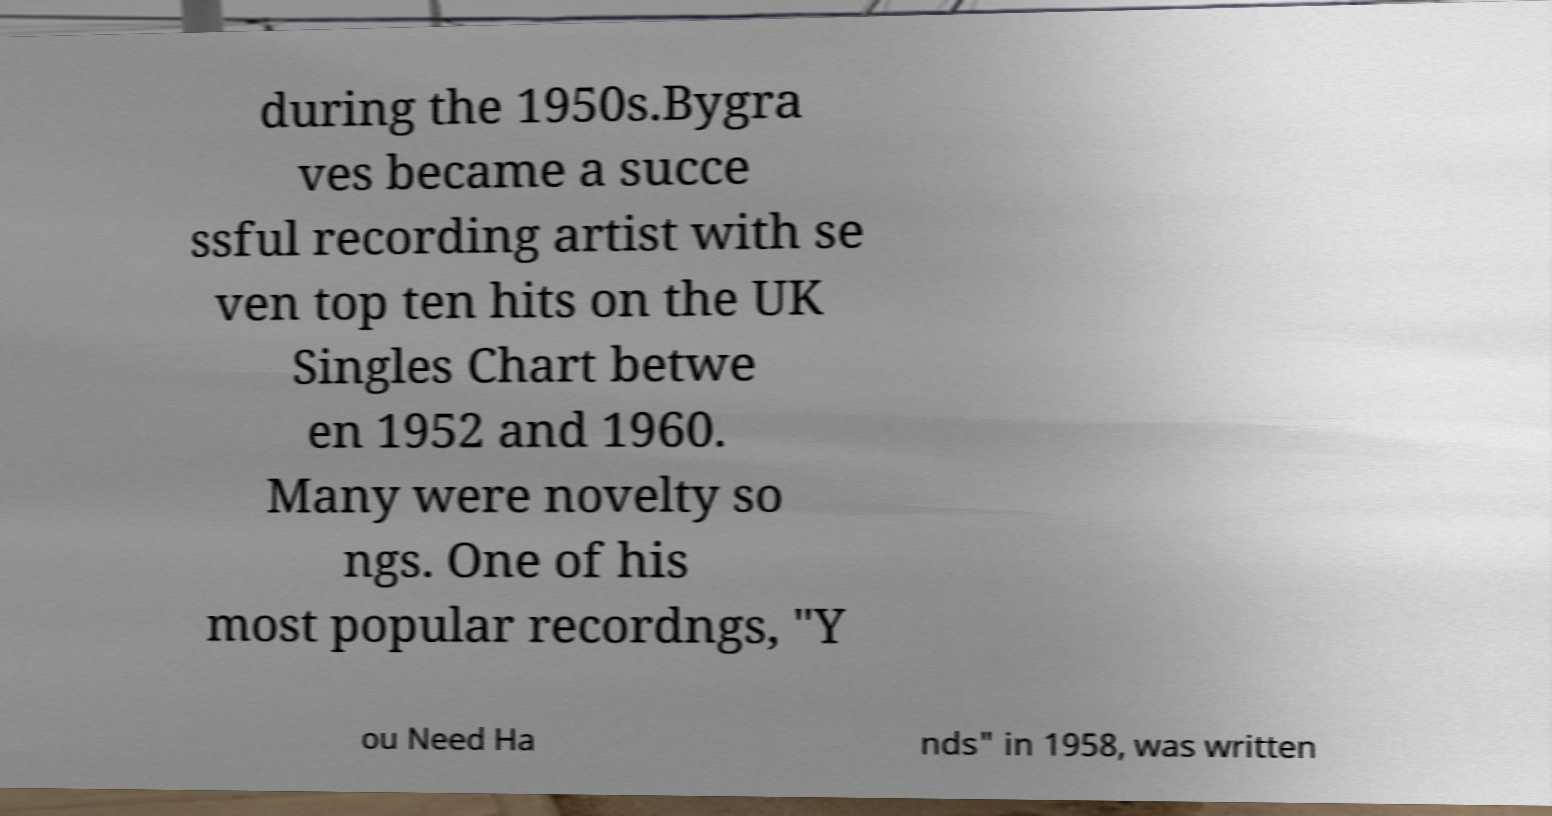Could you extract and type out the text from this image? during the 1950s.Bygra ves became a succe ssful recording artist with se ven top ten hits on the UK Singles Chart betwe en 1952 and 1960. Many were novelty so ngs. One of his most popular recordngs, "Y ou Need Ha nds" in 1958, was written 